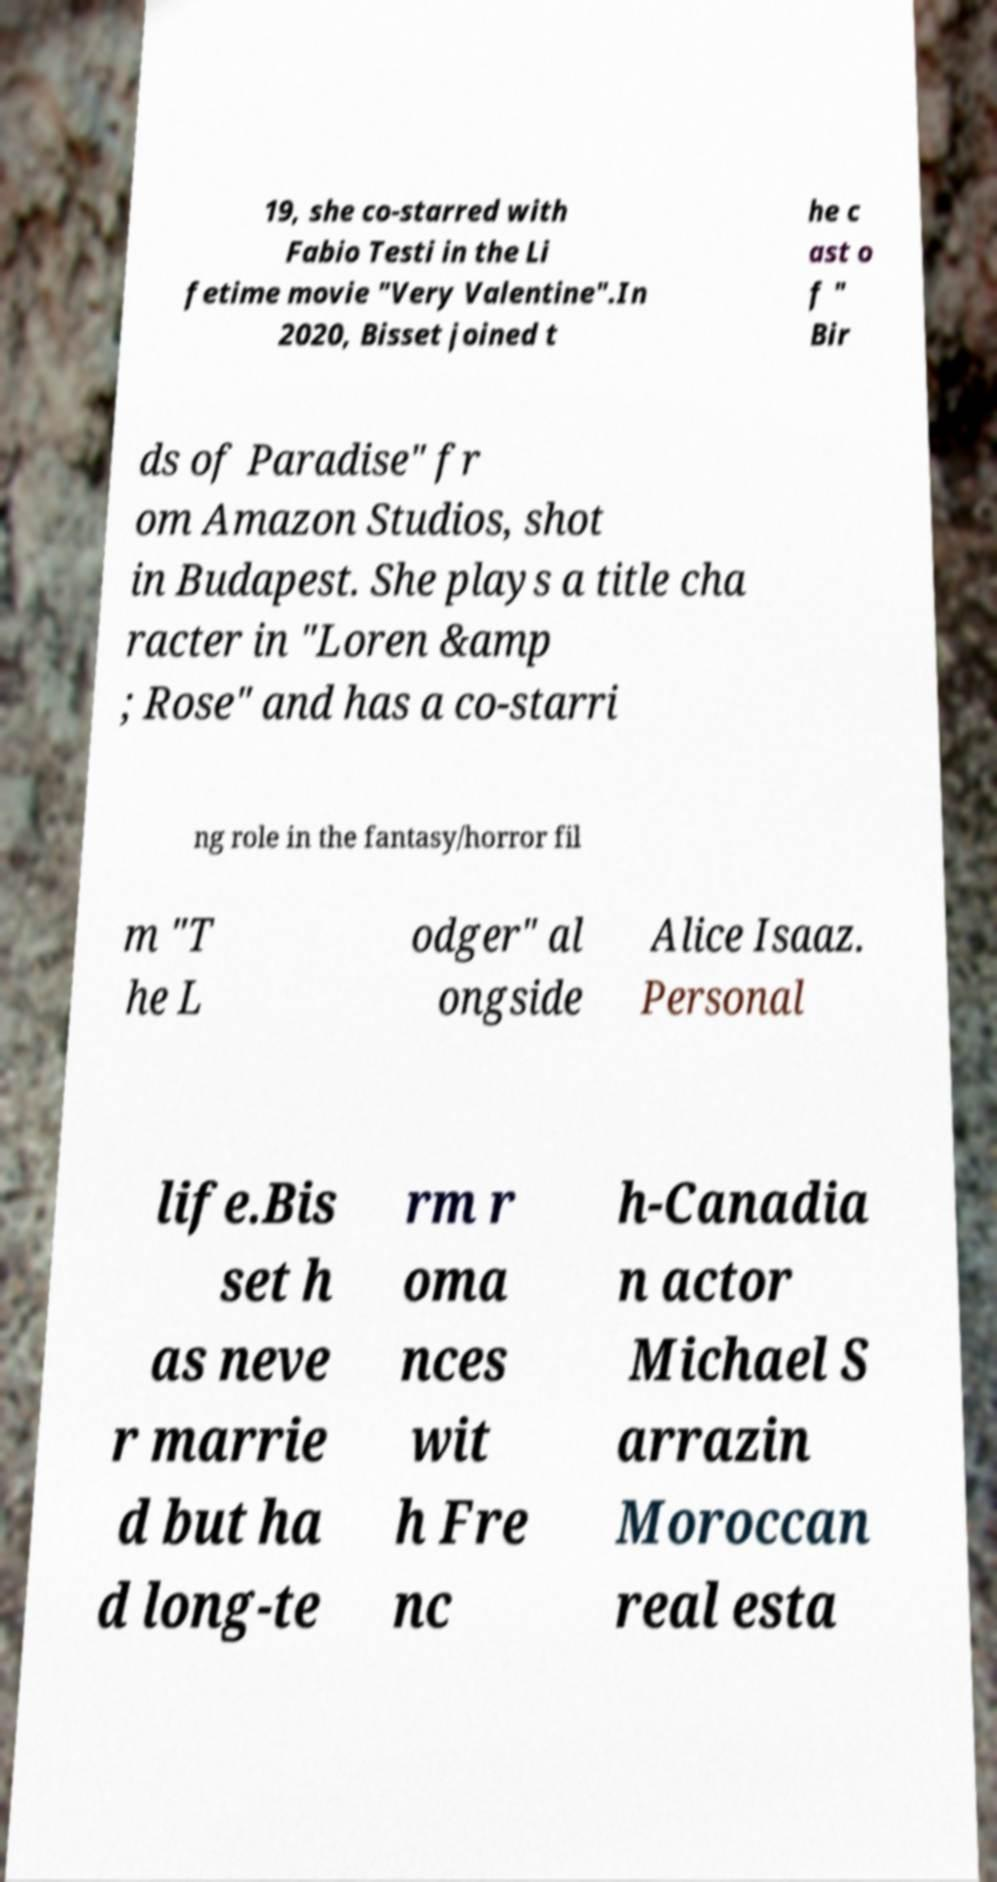Can you read and provide the text displayed in the image?This photo seems to have some interesting text. Can you extract and type it out for me? 19, she co-starred with Fabio Testi in the Li fetime movie "Very Valentine".In 2020, Bisset joined t he c ast o f " Bir ds of Paradise" fr om Amazon Studios, shot in Budapest. She plays a title cha racter in "Loren &amp ; Rose" and has a co-starri ng role in the fantasy/horror fil m "T he L odger" al ongside Alice Isaaz. Personal life.Bis set h as neve r marrie d but ha d long-te rm r oma nces wit h Fre nc h-Canadia n actor Michael S arrazin Moroccan real esta 